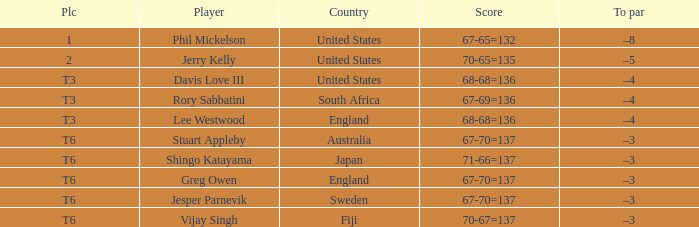Provide vijay singh's score. 70-67=137. Write the full table. {'header': ['Plc', 'Player', 'Country', 'Score', 'To par'], 'rows': [['1', 'Phil Mickelson', 'United States', '67-65=132', '–8'], ['2', 'Jerry Kelly', 'United States', '70-65=135', '–5'], ['T3', 'Davis Love III', 'United States', '68-68=136', '–4'], ['T3', 'Rory Sabbatini', 'South Africa', '67-69=136', '–4'], ['T3', 'Lee Westwood', 'England', '68-68=136', '–4'], ['T6', 'Stuart Appleby', 'Australia', '67-70=137', '–3'], ['T6', 'Shingo Katayama', 'Japan', '71-66=137', '–3'], ['T6', 'Greg Owen', 'England', '67-70=137', '–3'], ['T6', 'Jesper Parnevik', 'Sweden', '67-70=137', '–3'], ['T6', 'Vijay Singh', 'Fiji', '70-67=137', '–3']]} 